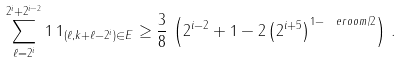Convert formula to latex. <formula><loc_0><loc_0><loc_500><loc_500>\sum _ { \ell = 2 ^ { i } } ^ { 2 ^ { i } + 2 ^ { i - 2 } } 1 \, 1 _ { ( \ell , k + \ell - 2 ^ { i } ) \in E } \geq \frac { 3 } { 8 } \, \left ( 2 ^ { i - 2 } + 1 - 2 \left ( 2 ^ { i + 5 } \right ) ^ { 1 - \ e r o o m / 2 } \right ) \, .</formula> 